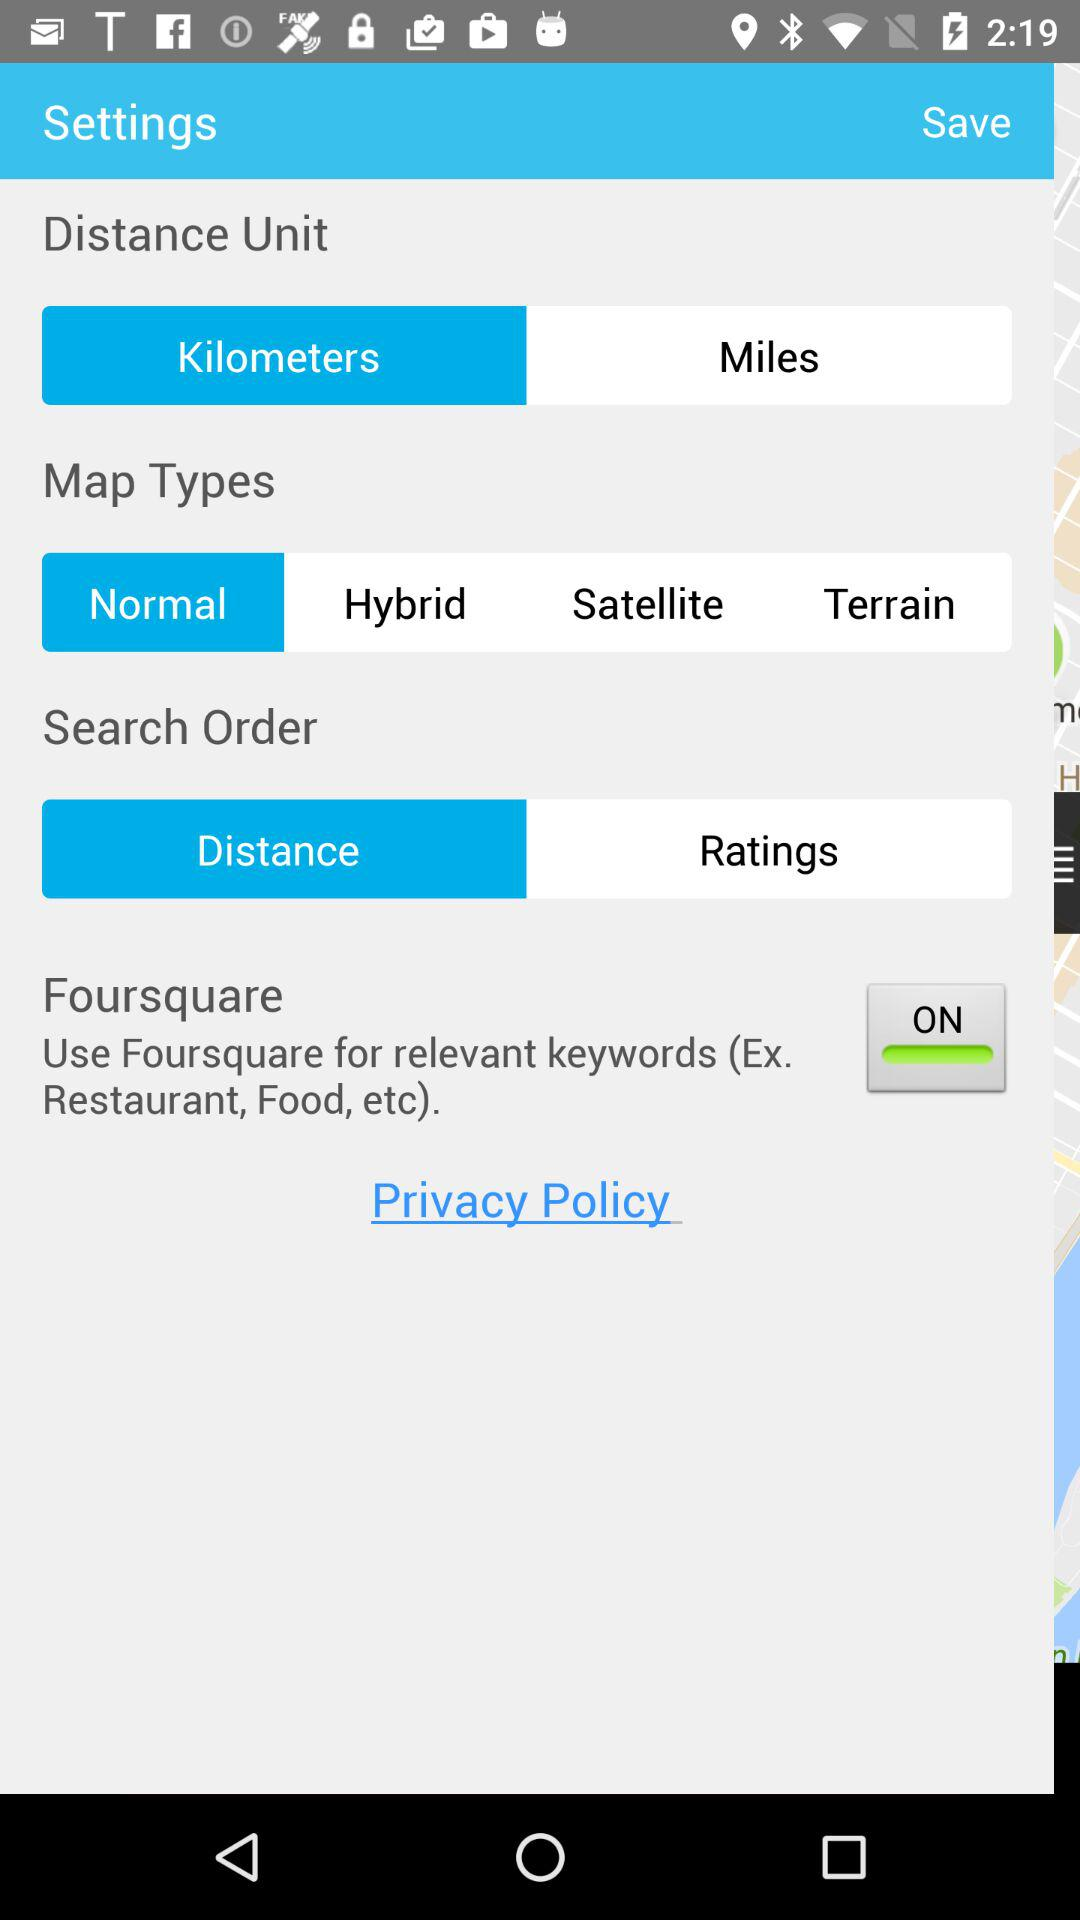Which option is selected in the "Map Types"? The selected option is "Normal". 